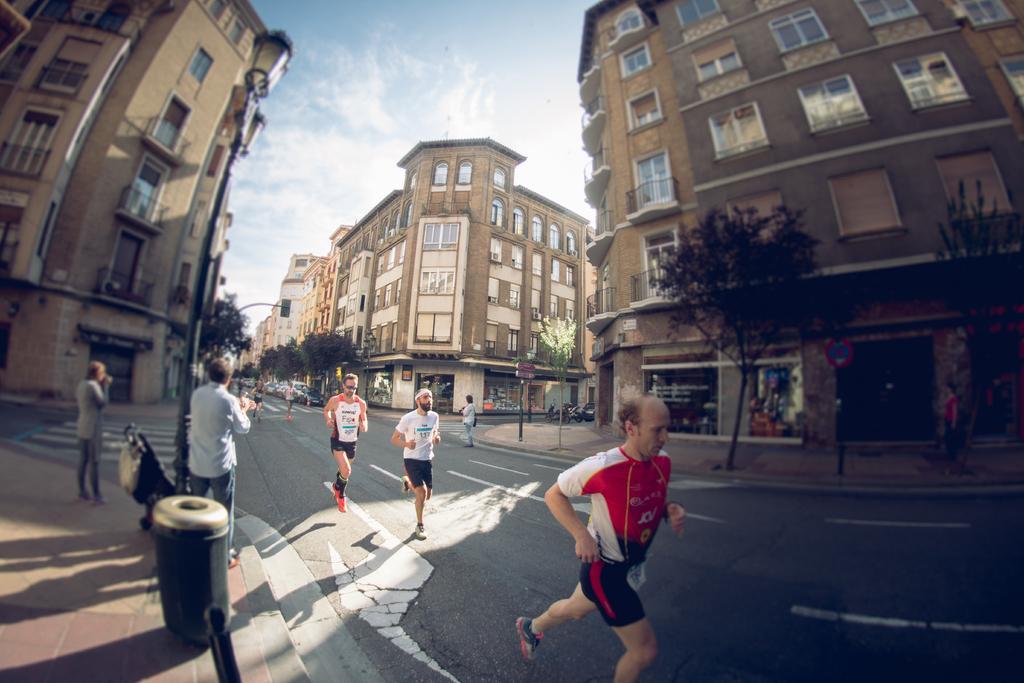How would you summarize this image in a sentence or two? In this picture we can see five persons are running, in the background there are some buildings and trees, on the left side there is a pole, light and a dustbin, on the right side we can see signboards, there are two persons standing on the left side, we can see the sky at the top of the picture. 